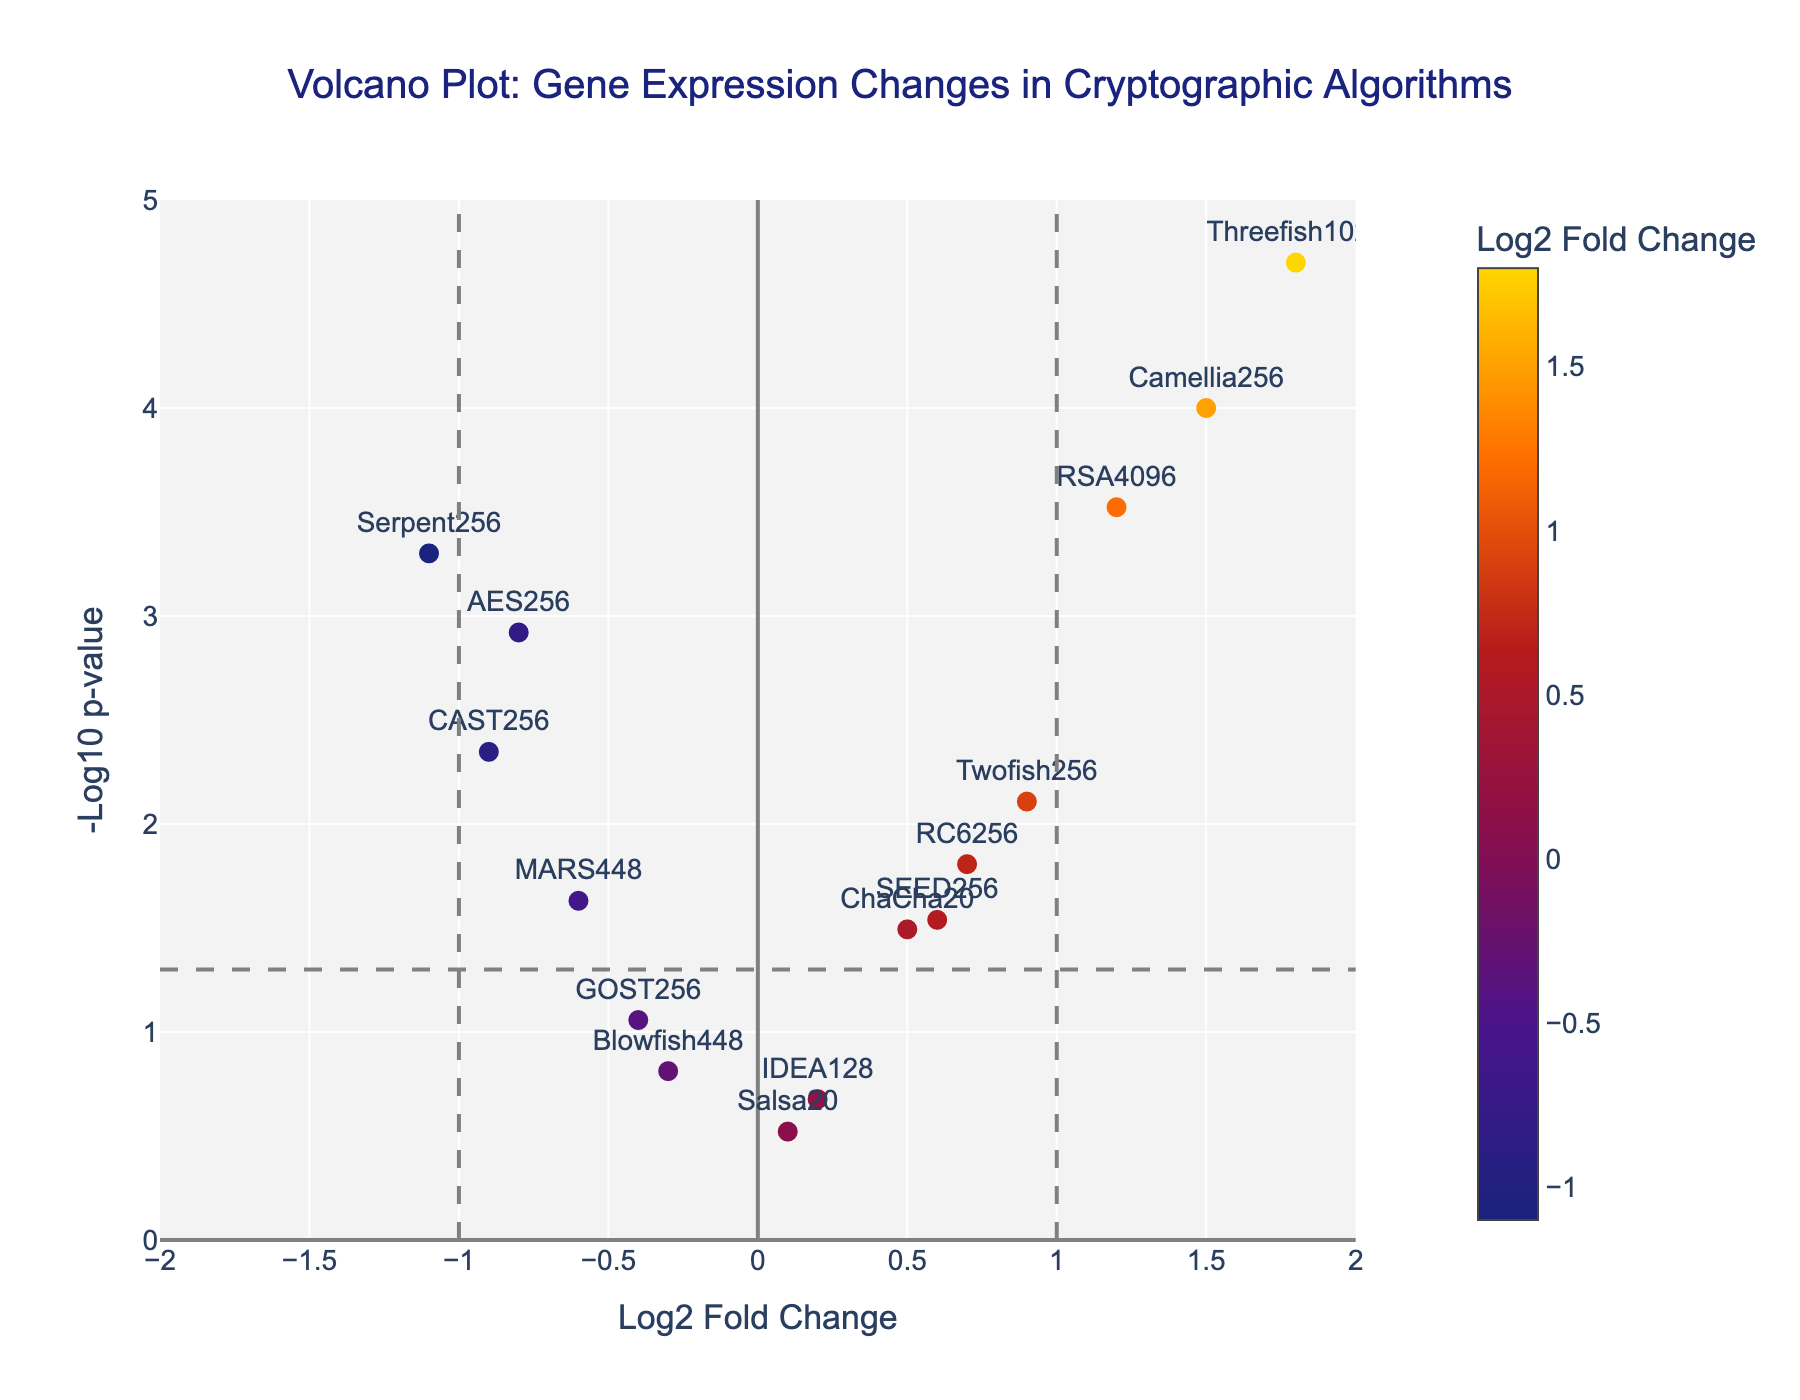How many genes exhibit a positive log2 fold change? Count all data points with positive log2 fold change values on the x-axis: RSA4096, ChaCha20, Twofish256, Camellia256, RC6256, Threefish1024, and SEED256.
Answer: 7 Which gene has the highest -log10 p-value? Locate the data point with the highest y-axis value. Threefish1024 has the highest -log10 p-value.
Answer: Threefish1024 Which gene has the greatest upregulation? Identify the data point with the highest positive log2 fold change. Threefish1024 has the greatest upregulation with a log2 fold change of 1.8.
Answer: Threefish1024 Are there any genes with a log2 fold change between -0.5 and 0.5? Identify genes within the range -0.5 to 0.5 on the x-axis: Blowfish448, IDEA128, Salsa20, and GOST256.
Answer: Blowfish448, IDEA128, Salsa20, GOST256 Which genes are considered statistically significant? Genes significant at p < 0.05 (with threshold line at -log10(0.05) ≈ 1.3). Identify genes with y-axis values above this line: AES256, RSA4096, ChaCha20, Twofish256, Serpent256, Camellia256, MARS448, RC6256, Threefish1024, CAST256, and SEED256.
Answer: AES256, RSA4096, ChaCha20, Twofish256, Serpent256, Camellia256, MARS448, RC6256, Threefish1024, CAST256, SEED256 How many genes exhibit log2 fold changes greater than 1? Count all data points with log2 fold changes greater than 1: RSA4096, Camellia256, and Threefish1024.
Answer: 3 What is the log2 fold change of the gene with the lowest p-value? Identify the gene with the lowest p-value and note its log2 fold change. The gene is Threefish1024, with a log2 fold change of 1.8.
Answer: 1.8 Which gene has the most downregulation? Identify the data point with the most negative log2 fold change. Serpent256 has the most downregulation with a log2 fold change of -1.1.
Answer: Serpent256 Which gene has a log2 fold change of approximately 0.7? Locate the data point at the x-axis value of approximately 0.7. The gene is RC6256.
Answer: RC6256 Are there more genes upregulated or downregulated? Compare the number of genes with positive log2 fold changes (7) to those with negative log2 fold changes (6). There are more upregulated genes (7) than downregulated genes (6).
Answer: More upregulated 